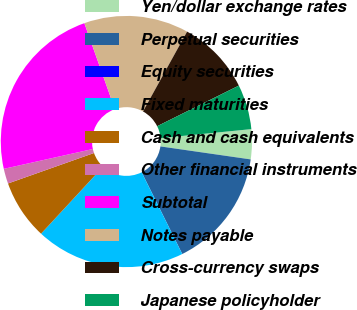<chart> <loc_0><loc_0><loc_500><loc_500><pie_chart><fcel>Yen/dollar exchange rates<fcel>Perpetual securities<fcel>Equity securities<fcel>Fixed maturities<fcel>Cash and cash equivalents<fcel>Other financial instruments<fcel>Subtotal<fcel>Notes payable<fcel>Cross-currency swaps<fcel>Japanese policyholder<nl><fcel>3.85%<fcel>15.38%<fcel>0.01%<fcel>19.22%<fcel>7.69%<fcel>1.93%<fcel>23.06%<fcel>13.46%<fcel>9.62%<fcel>5.77%<nl></chart> 